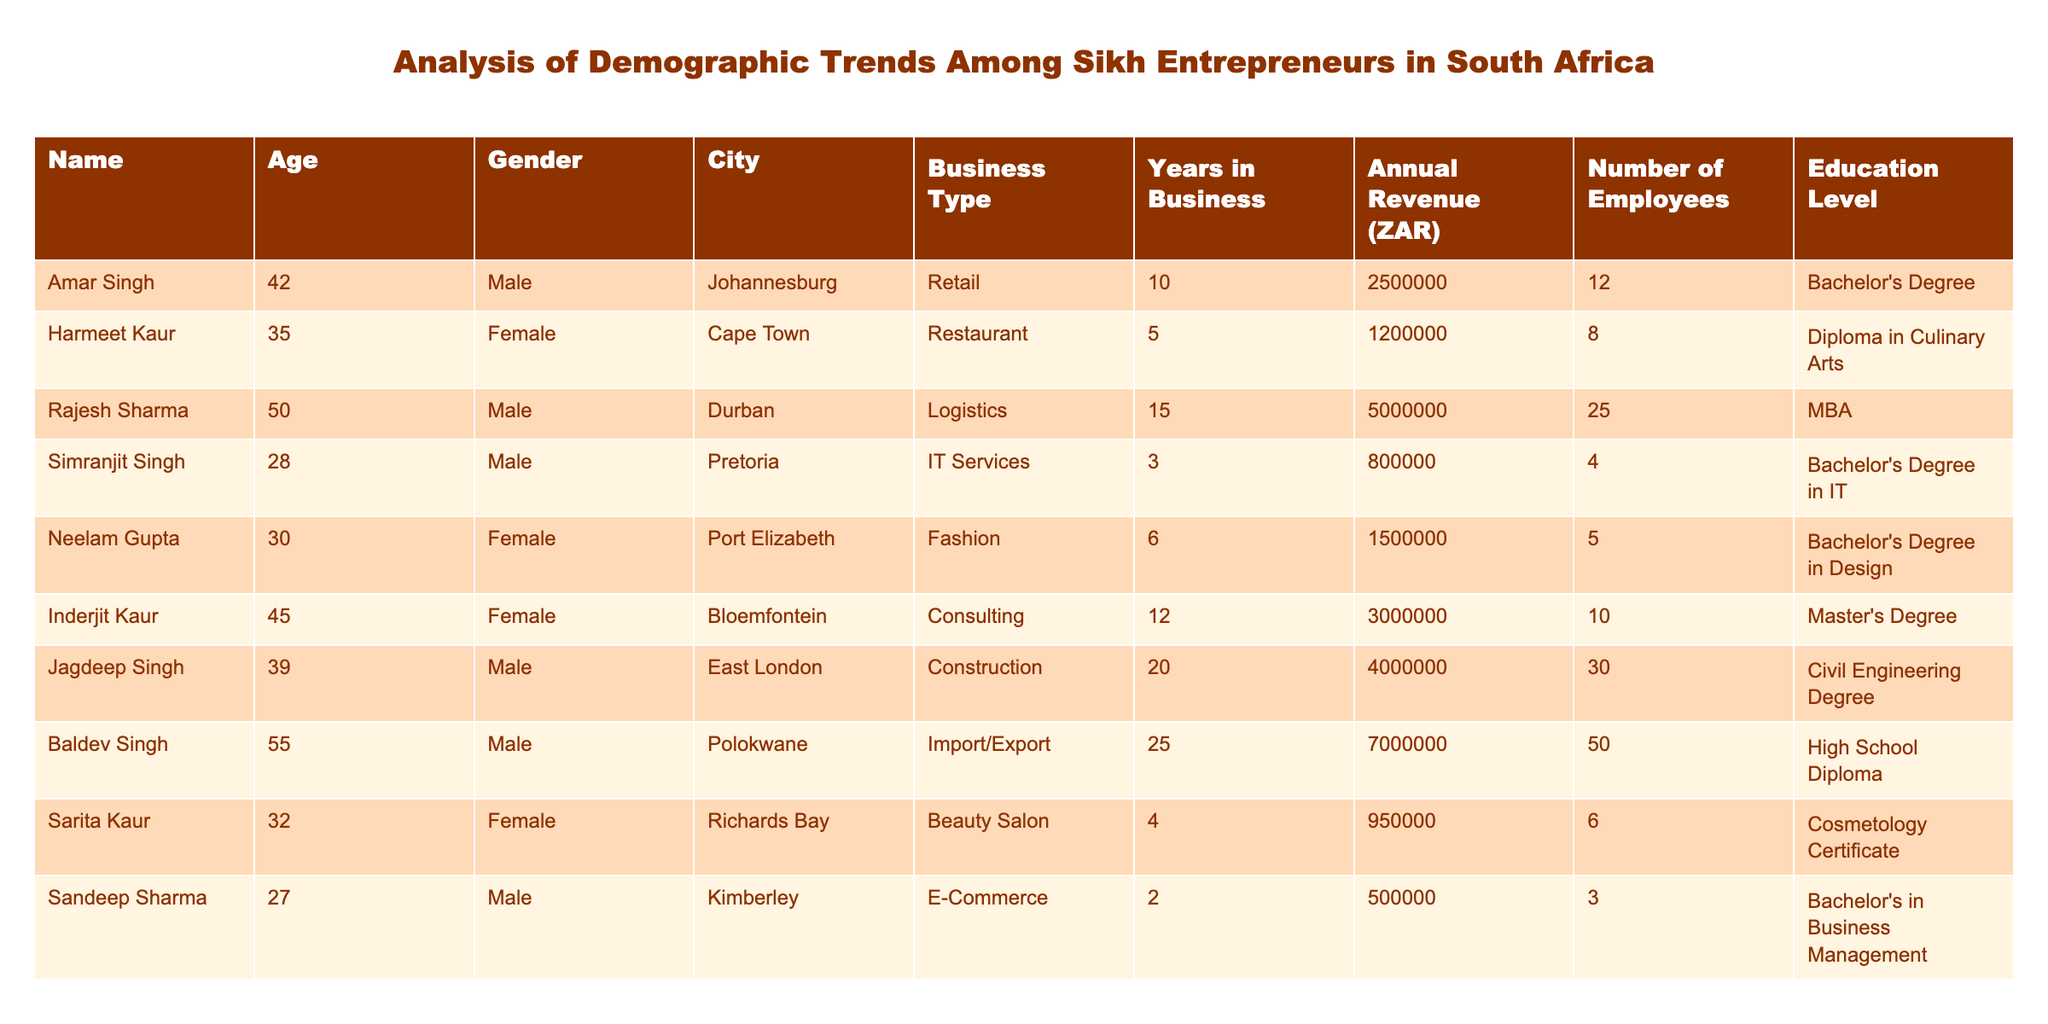What is the business type of Rajesh Sharma? Rajesh Sharma is listed under the "Business Type" column, where it indicates that he owns a logistics business.
Answer: Logistics How many employees does Neelam Gupta have? By looking at the "Number of Employees" column, Neelam Gupta is recorded to have 5 employees in her fashion business.
Answer: 5 What is the total annual revenue of all businesses listed in the table? To find the total annual revenue, sum the annual revenue figures: 2500000 + 1200000 + 5000000 + 800000 + 1500000 + 3000000 + 4000000 + 7000000 + 950000 + 500000 = 23650000 ZAR.
Answer: 23650000 ZAR Is there any female entrepreneur with a Master's degree? In the "Education Level" column, Inderjit Kaur is shown to have a Master's Degree, confirming there is indeed a female entrepreneur with that education level.
Answer: Yes What is the average age of all entrepreneurs in the table? The ages are: 42, 35, 50, 28, 30, 45, 39, 55, 32, 27. To find the average: (42 + 35 + 50 + 28 + 30 + 45 + 39 + 55 + 32 + 27) =  389, then divide by 10 (the total number of entrepreneurs) which gives an average age of 38.9.
Answer: 38.9 